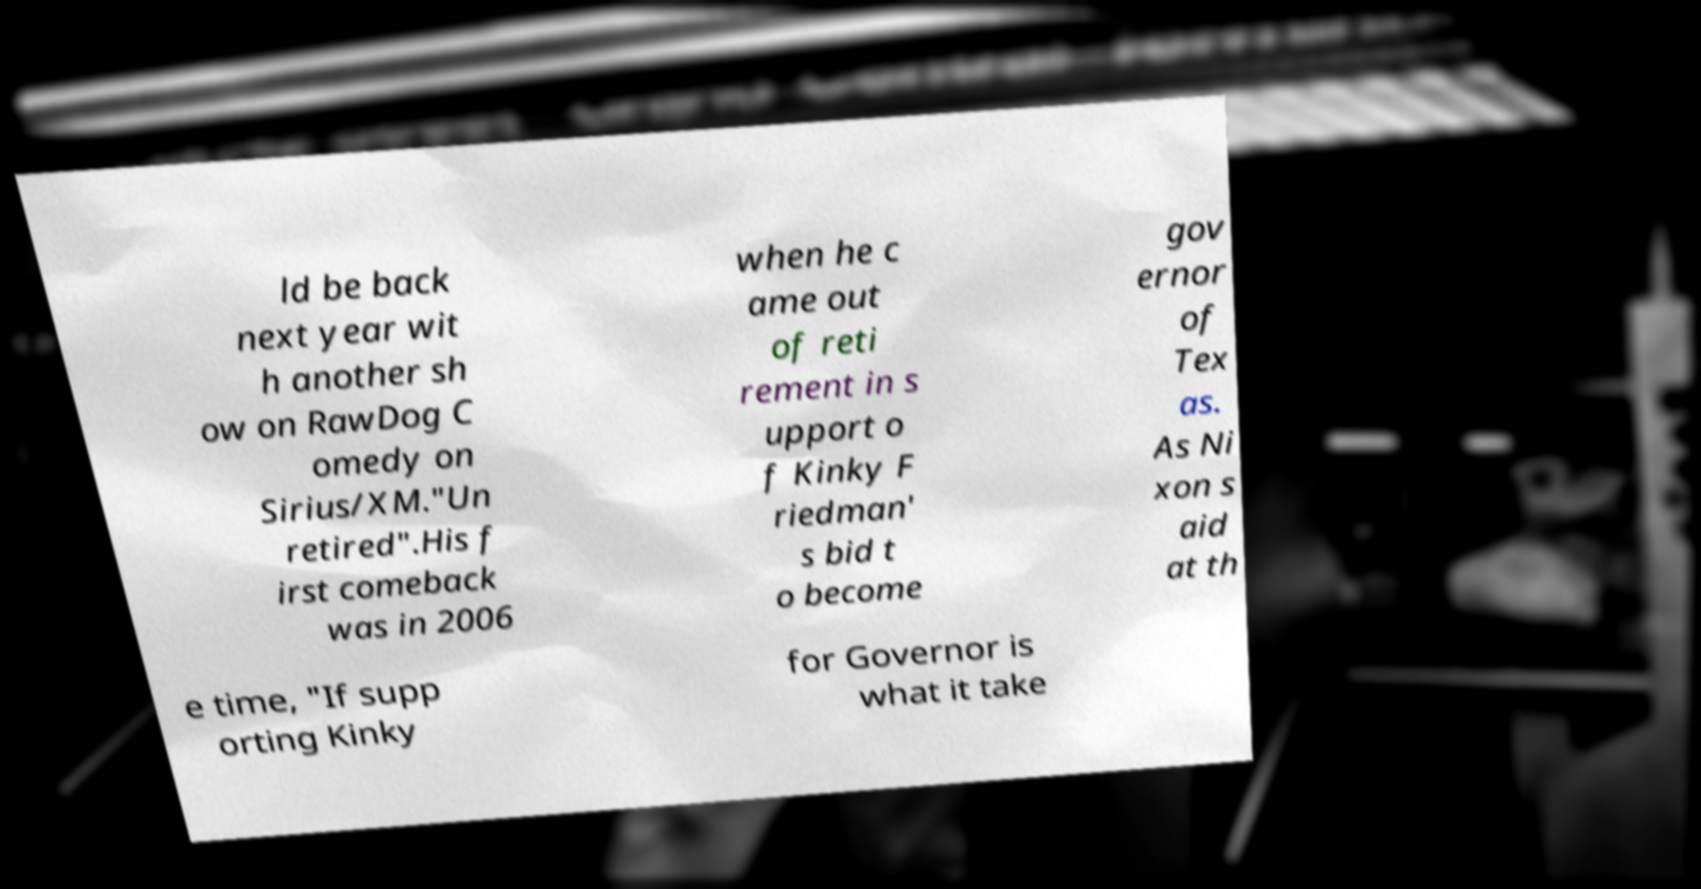What messages or text are displayed in this image? I need them in a readable, typed format. ld be back next year wit h another sh ow on RawDog C omedy on Sirius/XM."Un retired".His f irst comeback was in 2006 when he c ame out of reti rement in s upport o f Kinky F riedman' s bid t o become gov ernor of Tex as. As Ni xon s aid at th e time, "If supp orting Kinky for Governor is what it take 